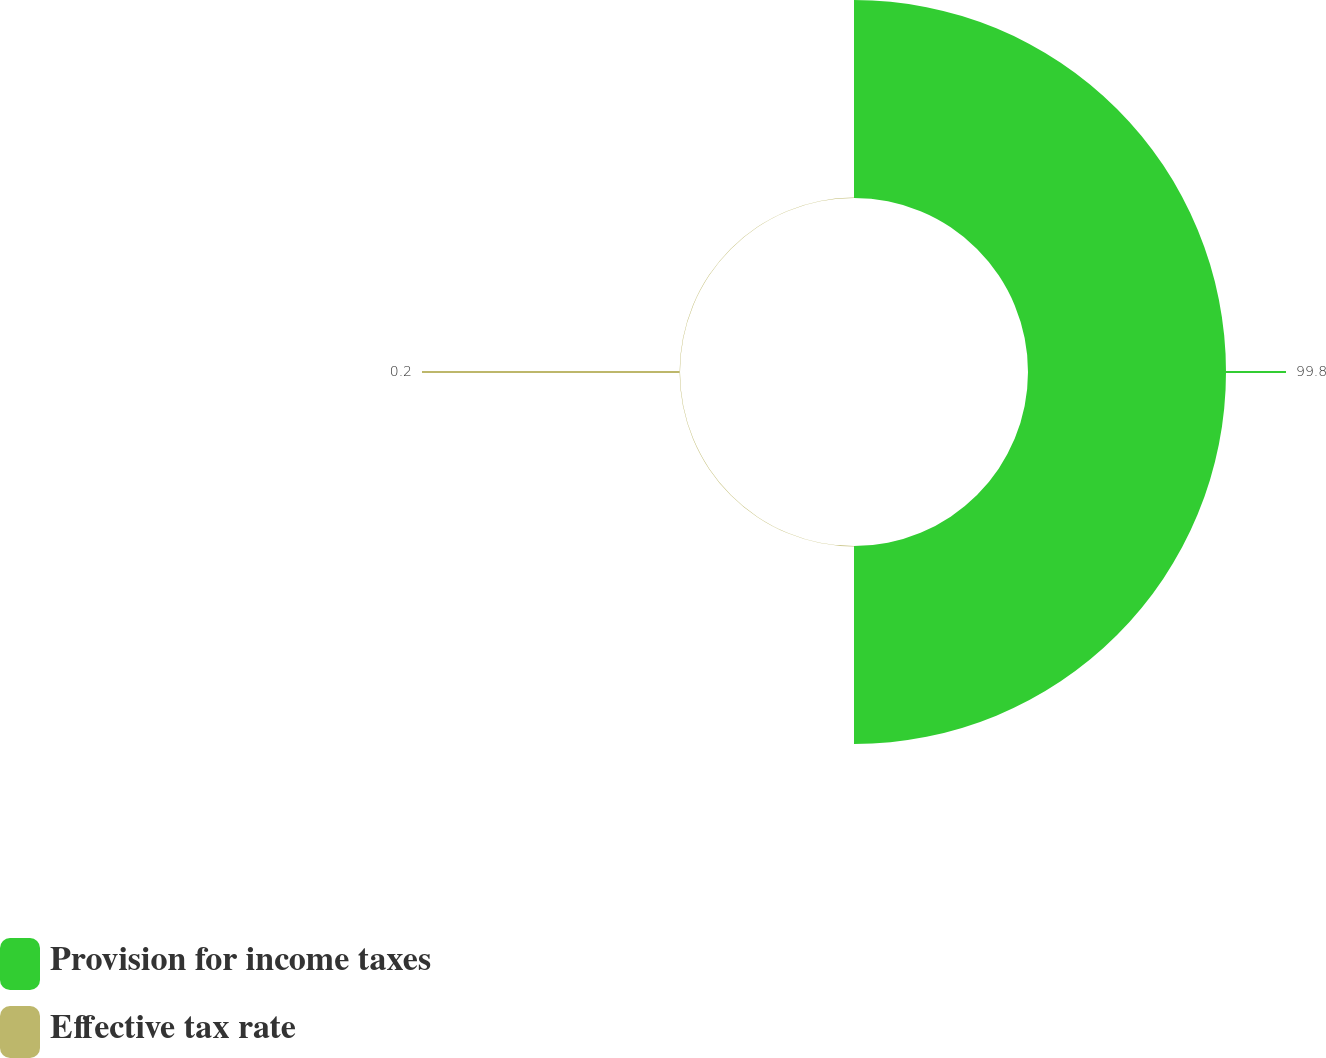<chart> <loc_0><loc_0><loc_500><loc_500><pie_chart><fcel>Provision for income taxes<fcel>Effective tax rate<nl><fcel>99.8%<fcel>0.2%<nl></chart> 